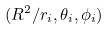<formula> <loc_0><loc_0><loc_500><loc_500>( R ^ { 2 } / r _ { i } , \theta _ { i } , \phi _ { i } )</formula> 